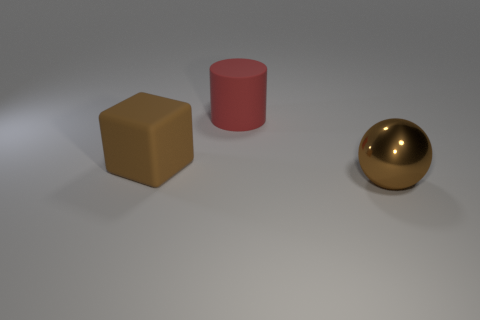There is a ball that is the same color as the cube; what is it made of?
Make the answer very short. Metal. What number of objects are either tiny purple metal cylinders or big brown things in front of the large rubber block?
Offer a terse response. 1. What is the size of the other object that is made of the same material as the large red thing?
Offer a very short reply. Large. There is a brown thing to the right of the large brown object left of the brown shiny sphere; what is its shape?
Your response must be concise. Sphere. There is a thing that is right of the large brown matte thing and in front of the big cylinder; what is its size?
Your answer should be very brief. Large. Are there any other big objects that have the same shape as the red matte thing?
Your answer should be compact. No. Is there anything else that is the same shape as the red thing?
Offer a terse response. No. There is a brown object behind the large thing in front of the rubber object that is on the left side of the big red matte cylinder; what is its material?
Your answer should be very brief. Rubber. Is there a shiny thing of the same size as the brown rubber cube?
Give a very brief answer. Yes. The object that is to the right of the object behind the large rubber cube is what color?
Keep it short and to the point. Brown. 